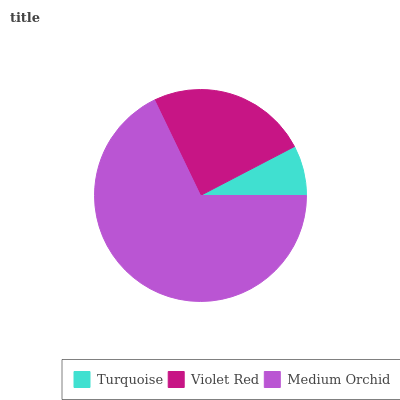Is Turquoise the minimum?
Answer yes or no. Yes. Is Medium Orchid the maximum?
Answer yes or no. Yes. Is Violet Red the minimum?
Answer yes or no. No. Is Violet Red the maximum?
Answer yes or no. No. Is Violet Red greater than Turquoise?
Answer yes or no. Yes. Is Turquoise less than Violet Red?
Answer yes or no. Yes. Is Turquoise greater than Violet Red?
Answer yes or no. No. Is Violet Red less than Turquoise?
Answer yes or no. No. Is Violet Red the high median?
Answer yes or no. Yes. Is Violet Red the low median?
Answer yes or no. Yes. Is Medium Orchid the high median?
Answer yes or no. No. Is Turquoise the low median?
Answer yes or no. No. 